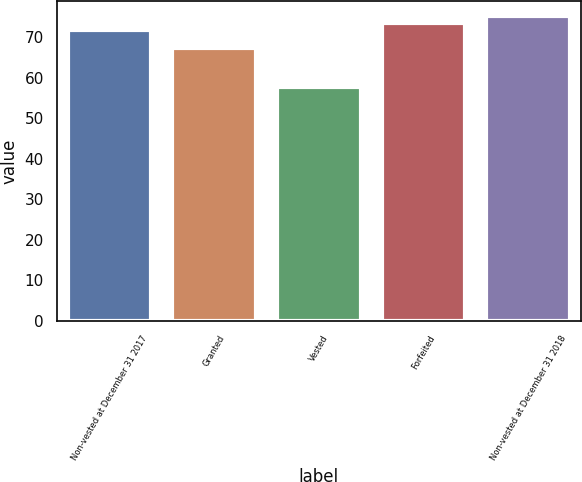Convert chart. <chart><loc_0><loc_0><loc_500><loc_500><bar_chart><fcel>Non-vested at December 31 2017<fcel>Granted<fcel>Vested<fcel>Forfeited<fcel>Non-vested at December 31 2018<nl><fcel>71.74<fcel>67.26<fcel>57.77<fcel>73.44<fcel>75.14<nl></chart> 